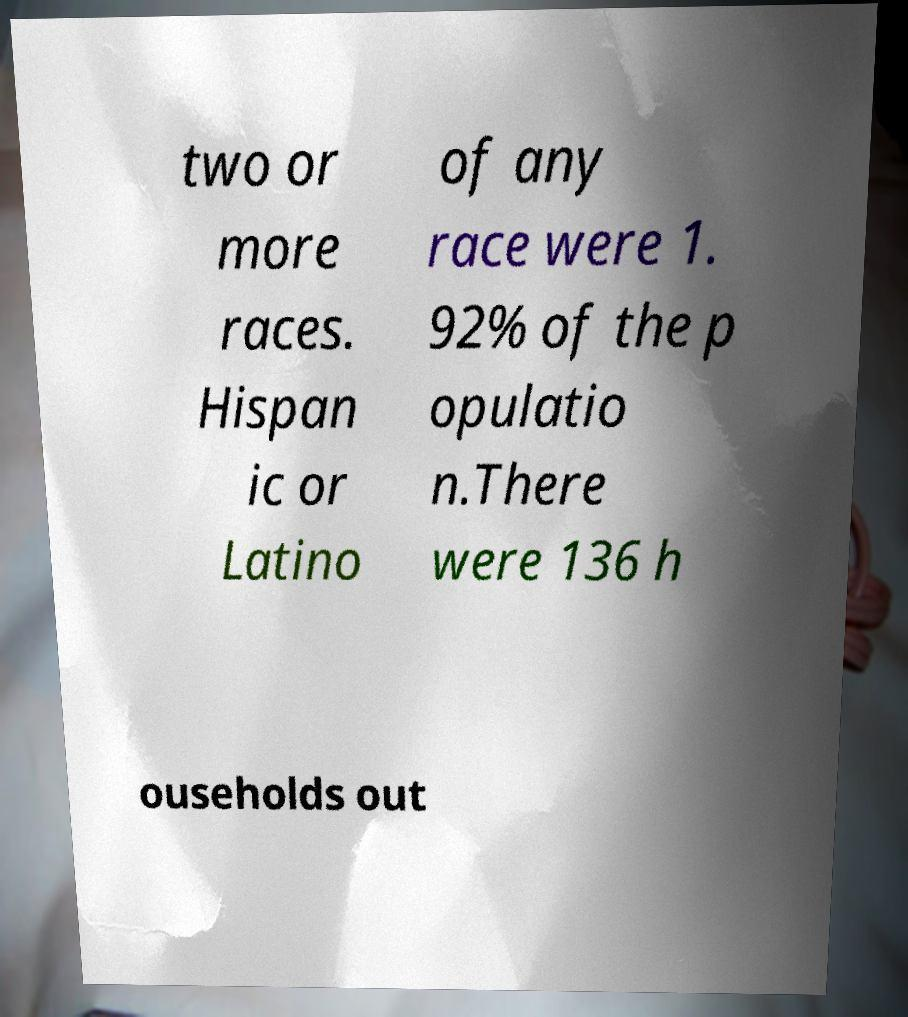Can you read and provide the text displayed in the image?This photo seems to have some interesting text. Can you extract and type it out for me? two or more races. Hispan ic or Latino of any race were 1. 92% of the p opulatio n.There were 136 h ouseholds out 